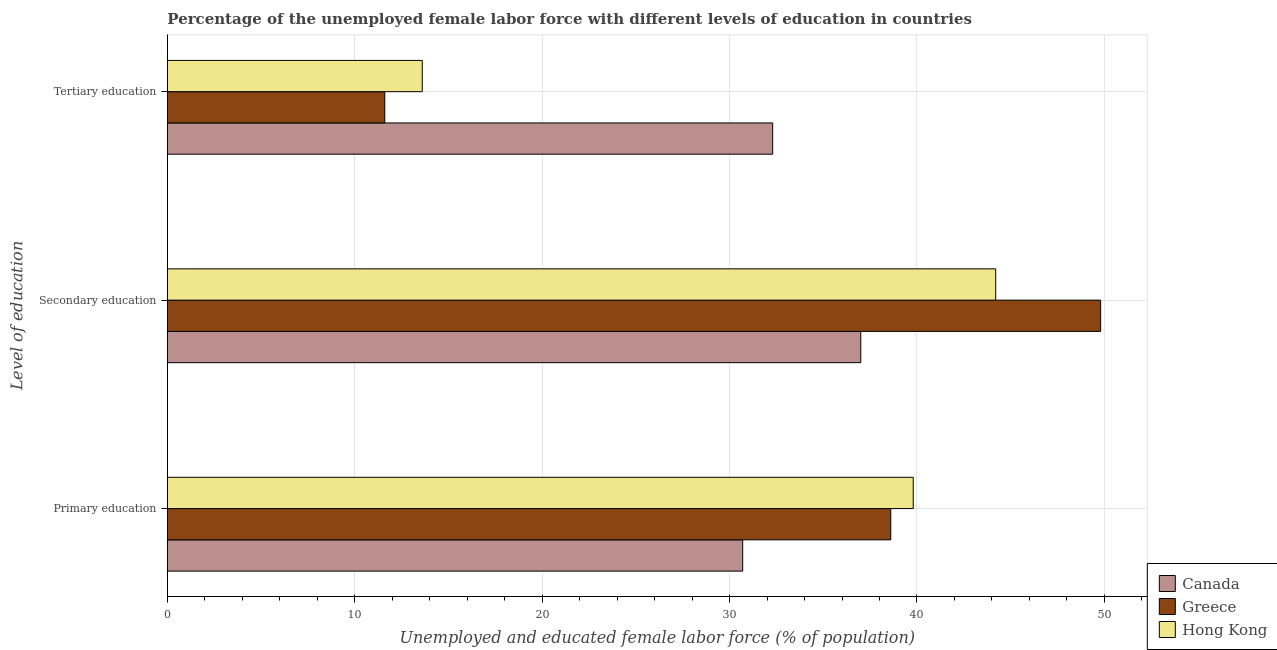Are the number of bars per tick equal to the number of legend labels?
Provide a succinct answer. Yes. Are the number of bars on each tick of the Y-axis equal?
Offer a very short reply. Yes. How many bars are there on the 3rd tick from the bottom?
Give a very brief answer. 3. What is the percentage of female labor force who received secondary education in Greece?
Provide a short and direct response. 49.8. Across all countries, what is the maximum percentage of female labor force who received primary education?
Your answer should be very brief. 39.8. Across all countries, what is the minimum percentage of female labor force who received secondary education?
Provide a short and direct response. 37. In which country was the percentage of female labor force who received tertiary education minimum?
Keep it short and to the point. Greece. What is the total percentage of female labor force who received primary education in the graph?
Your answer should be compact. 109.1. What is the difference between the percentage of female labor force who received secondary education in Hong Kong and that in Canada?
Give a very brief answer. 7.2. What is the difference between the percentage of female labor force who received primary education in Greece and the percentage of female labor force who received tertiary education in Canada?
Provide a succinct answer. 6.3. What is the average percentage of female labor force who received tertiary education per country?
Provide a succinct answer. 19.17. What is the difference between the percentage of female labor force who received tertiary education and percentage of female labor force who received secondary education in Hong Kong?
Make the answer very short. -30.6. In how many countries, is the percentage of female labor force who received primary education greater than 28 %?
Your response must be concise. 3. What is the ratio of the percentage of female labor force who received primary education in Canada to that in Hong Kong?
Keep it short and to the point. 0.77. What is the difference between the highest and the second highest percentage of female labor force who received tertiary education?
Your response must be concise. 18.7. What is the difference between the highest and the lowest percentage of female labor force who received tertiary education?
Offer a terse response. 20.7. In how many countries, is the percentage of female labor force who received primary education greater than the average percentage of female labor force who received primary education taken over all countries?
Offer a terse response. 2. Is the sum of the percentage of female labor force who received primary education in Hong Kong and Greece greater than the maximum percentage of female labor force who received tertiary education across all countries?
Make the answer very short. Yes. What does the 2nd bar from the top in Primary education represents?
Your answer should be compact. Greece. Is it the case that in every country, the sum of the percentage of female labor force who received primary education and percentage of female labor force who received secondary education is greater than the percentage of female labor force who received tertiary education?
Your answer should be very brief. Yes. How many bars are there?
Give a very brief answer. 9. Are the values on the major ticks of X-axis written in scientific E-notation?
Ensure brevity in your answer.  No. Does the graph contain any zero values?
Your response must be concise. No. Where does the legend appear in the graph?
Provide a short and direct response. Bottom right. How many legend labels are there?
Ensure brevity in your answer.  3. How are the legend labels stacked?
Ensure brevity in your answer.  Vertical. What is the title of the graph?
Offer a terse response. Percentage of the unemployed female labor force with different levels of education in countries. Does "Small states" appear as one of the legend labels in the graph?
Offer a terse response. No. What is the label or title of the X-axis?
Provide a short and direct response. Unemployed and educated female labor force (% of population). What is the label or title of the Y-axis?
Make the answer very short. Level of education. What is the Unemployed and educated female labor force (% of population) in Canada in Primary education?
Offer a very short reply. 30.7. What is the Unemployed and educated female labor force (% of population) of Greece in Primary education?
Your answer should be compact. 38.6. What is the Unemployed and educated female labor force (% of population) of Hong Kong in Primary education?
Your answer should be compact. 39.8. What is the Unemployed and educated female labor force (% of population) of Canada in Secondary education?
Your response must be concise. 37. What is the Unemployed and educated female labor force (% of population) of Greece in Secondary education?
Offer a very short reply. 49.8. What is the Unemployed and educated female labor force (% of population) in Hong Kong in Secondary education?
Keep it short and to the point. 44.2. What is the Unemployed and educated female labor force (% of population) of Canada in Tertiary education?
Offer a terse response. 32.3. What is the Unemployed and educated female labor force (% of population) in Greece in Tertiary education?
Keep it short and to the point. 11.6. What is the Unemployed and educated female labor force (% of population) in Hong Kong in Tertiary education?
Your answer should be very brief. 13.6. Across all Level of education, what is the maximum Unemployed and educated female labor force (% of population) of Canada?
Ensure brevity in your answer.  37. Across all Level of education, what is the maximum Unemployed and educated female labor force (% of population) in Greece?
Your answer should be compact. 49.8. Across all Level of education, what is the maximum Unemployed and educated female labor force (% of population) of Hong Kong?
Ensure brevity in your answer.  44.2. Across all Level of education, what is the minimum Unemployed and educated female labor force (% of population) in Canada?
Keep it short and to the point. 30.7. Across all Level of education, what is the minimum Unemployed and educated female labor force (% of population) of Greece?
Provide a short and direct response. 11.6. Across all Level of education, what is the minimum Unemployed and educated female labor force (% of population) of Hong Kong?
Provide a short and direct response. 13.6. What is the total Unemployed and educated female labor force (% of population) in Canada in the graph?
Offer a terse response. 100. What is the total Unemployed and educated female labor force (% of population) in Greece in the graph?
Provide a succinct answer. 100. What is the total Unemployed and educated female labor force (% of population) in Hong Kong in the graph?
Give a very brief answer. 97.6. What is the difference between the Unemployed and educated female labor force (% of population) in Canada in Primary education and that in Tertiary education?
Offer a terse response. -1.6. What is the difference between the Unemployed and educated female labor force (% of population) of Greece in Primary education and that in Tertiary education?
Keep it short and to the point. 27. What is the difference between the Unemployed and educated female labor force (% of population) in Hong Kong in Primary education and that in Tertiary education?
Provide a short and direct response. 26.2. What is the difference between the Unemployed and educated female labor force (% of population) of Canada in Secondary education and that in Tertiary education?
Make the answer very short. 4.7. What is the difference between the Unemployed and educated female labor force (% of population) of Greece in Secondary education and that in Tertiary education?
Your answer should be compact. 38.2. What is the difference between the Unemployed and educated female labor force (% of population) in Hong Kong in Secondary education and that in Tertiary education?
Give a very brief answer. 30.6. What is the difference between the Unemployed and educated female labor force (% of population) in Canada in Primary education and the Unemployed and educated female labor force (% of population) in Greece in Secondary education?
Offer a very short reply. -19.1. What is the difference between the Unemployed and educated female labor force (% of population) in Canada in Primary education and the Unemployed and educated female labor force (% of population) in Hong Kong in Secondary education?
Ensure brevity in your answer.  -13.5. What is the difference between the Unemployed and educated female labor force (% of population) in Canada in Primary education and the Unemployed and educated female labor force (% of population) in Greece in Tertiary education?
Provide a short and direct response. 19.1. What is the difference between the Unemployed and educated female labor force (% of population) of Canada in Secondary education and the Unemployed and educated female labor force (% of population) of Greece in Tertiary education?
Ensure brevity in your answer.  25.4. What is the difference between the Unemployed and educated female labor force (% of population) of Canada in Secondary education and the Unemployed and educated female labor force (% of population) of Hong Kong in Tertiary education?
Your response must be concise. 23.4. What is the difference between the Unemployed and educated female labor force (% of population) of Greece in Secondary education and the Unemployed and educated female labor force (% of population) of Hong Kong in Tertiary education?
Your answer should be very brief. 36.2. What is the average Unemployed and educated female labor force (% of population) of Canada per Level of education?
Your answer should be very brief. 33.33. What is the average Unemployed and educated female labor force (% of population) of Greece per Level of education?
Your answer should be very brief. 33.33. What is the average Unemployed and educated female labor force (% of population) in Hong Kong per Level of education?
Your answer should be compact. 32.53. What is the difference between the Unemployed and educated female labor force (% of population) of Canada and Unemployed and educated female labor force (% of population) of Greece in Primary education?
Make the answer very short. -7.9. What is the difference between the Unemployed and educated female labor force (% of population) in Greece and Unemployed and educated female labor force (% of population) in Hong Kong in Primary education?
Make the answer very short. -1.2. What is the difference between the Unemployed and educated female labor force (% of population) of Canada and Unemployed and educated female labor force (% of population) of Hong Kong in Secondary education?
Provide a short and direct response. -7.2. What is the difference between the Unemployed and educated female labor force (% of population) in Canada and Unemployed and educated female labor force (% of population) in Greece in Tertiary education?
Offer a very short reply. 20.7. What is the difference between the Unemployed and educated female labor force (% of population) of Canada and Unemployed and educated female labor force (% of population) of Hong Kong in Tertiary education?
Ensure brevity in your answer.  18.7. What is the ratio of the Unemployed and educated female labor force (% of population) of Canada in Primary education to that in Secondary education?
Offer a terse response. 0.83. What is the ratio of the Unemployed and educated female labor force (% of population) in Greece in Primary education to that in Secondary education?
Give a very brief answer. 0.78. What is the ratio of the Unemployed and educated female labor force (% of population) of Hong Kong in Primary education to that in Secondary education?
Make the answer very short. 0.9. What is the ratio of the Unemployed and educated female labor force (% of population) in Canada in Primary education to that in Tertiary education?
Offer a very short reply. 0.95. What is the ratio of the Unemployed and educated female labor force (% of population) in Greece in Primary education to that in Tertiary education?
Give a very brief answer. 3.33. What is the ratio of the Unemployed and educated female labor force (% of population) in Hong Kong in Primary education to that in Tertiary education?
Make the answer very short. 2.93. What is the ratio of the Unemployed and educated female labor force (% of population) of Canada in Secondary education to that in Tertiary education?
Your response must be concise. 1.15. What is the ratio of the Unemployed and educated female labor force (% of population) in Greece in Secondary education to that in Tertiary education?
Provide a succinct answer. 4.29. What is the difference between the highest and the second highest Unemployed and educated female labor force (% of population) in Hong Kong?
Your response must be concise. 4.4. What is the difference between the highest and the lowest Unemployed and educated female labor force (% of population) of Greece?
Give a very brief answer. 38.2. What is the difference between the highest and the lowest Unemployed and educated female labor force (% of population) of Hong Kong?
Your answer should be compact. 30.6. 